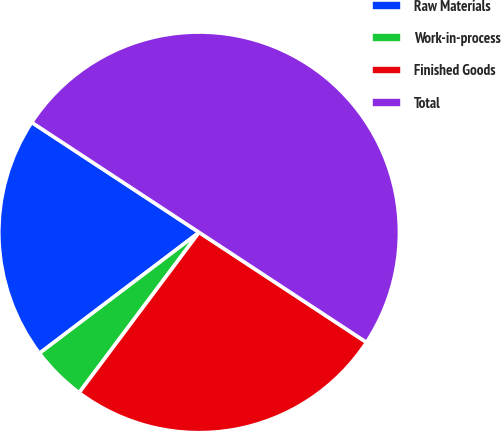<chart> <loc_0><loc_0><loc_500><loc_500><pie_chart><fcel>Raw Materials<fcel>Work-in-process<fcel>Finished Goods<fcel>Total<nl><fcel>19.57%<fcel>4.46%<fcel>25.97%<fcel>50.0%<nl></chart> 